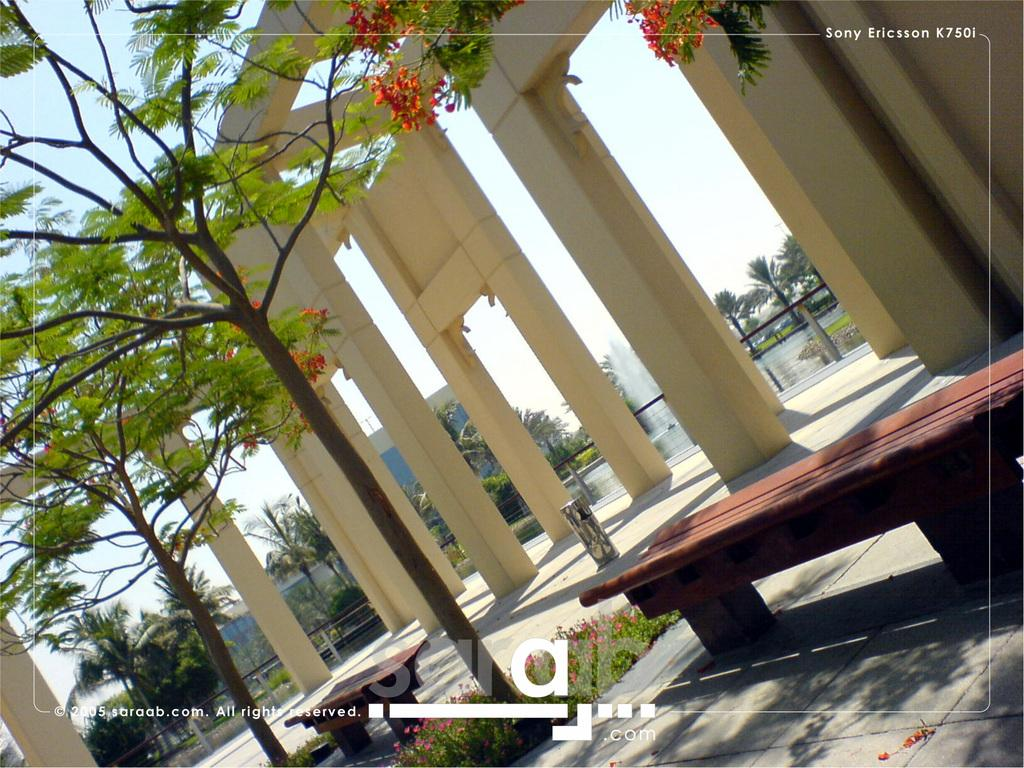What type of vegetation can be seen in the image? There are trees, plants, and flowers in the image. What type of seating is available in the image? There are benches in the image. What type of text is present in the image? There is text in the image. What architectural features can be seen in the background of the image? In the background of the image, there are pillars, a fence, a water fountain, and a building. What part of the natural environment is visible in the image? In the background of the image, there are more trees and plants. What part of the sky is visible in the image? In the background of the image, there is sky visible. How many attempts does it take for the flowers to crack the fence in the image? There are no flowers attempting to crack the fence in the image. What is the mind of the building in the background of the image? The building in the background of the image does not have a mind. 